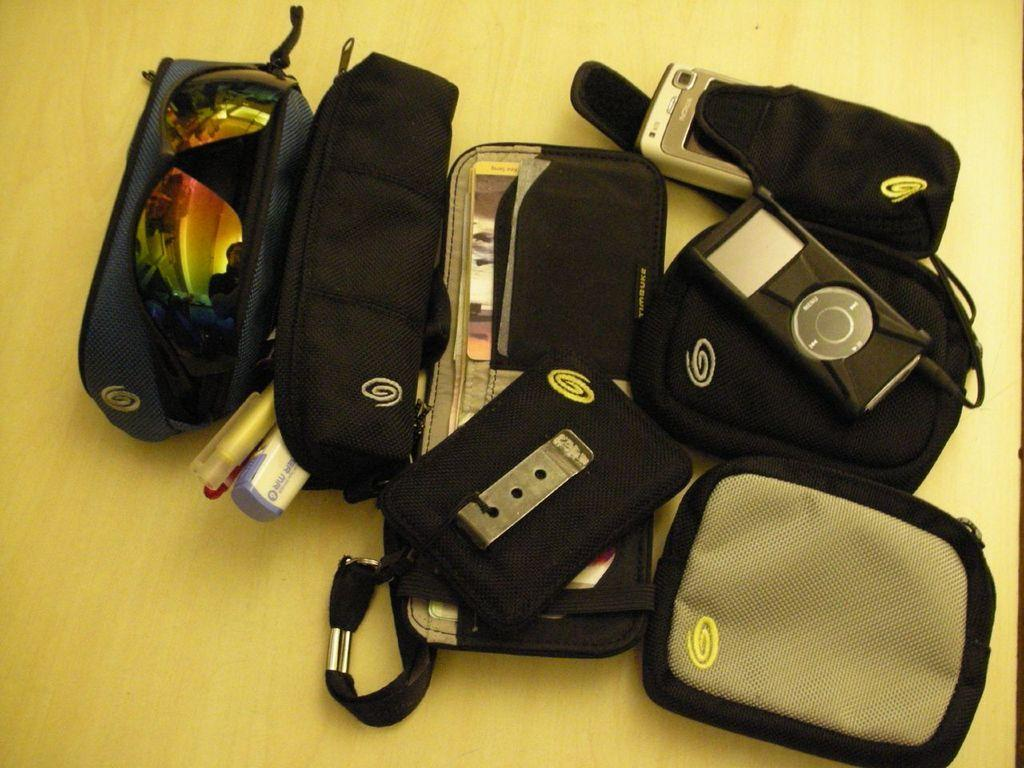What is located at the bottom of the image? There is a table at the bottom of the image. What items can be seen on the table? There are boxes, bags, glasses, and electronic devices on the table. How many types of items are present on the table? There are four types of items present on the table: boxes, bags, glasses, and electronic devices. Can you see any lumber being used in the image? There is no lumber present in the image. What type of smile can be seen on the electronic devices in the image? There are no smiles present in the image, as electronic devices do not have facial expressions. 